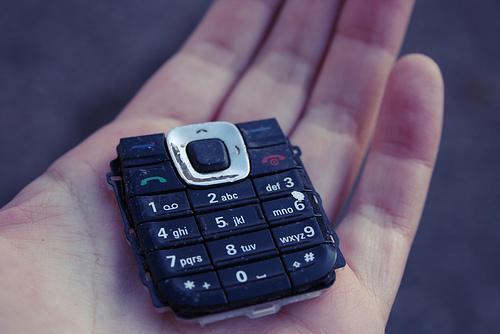How many things is the hand holding?
Give a very brief answer. 1. 